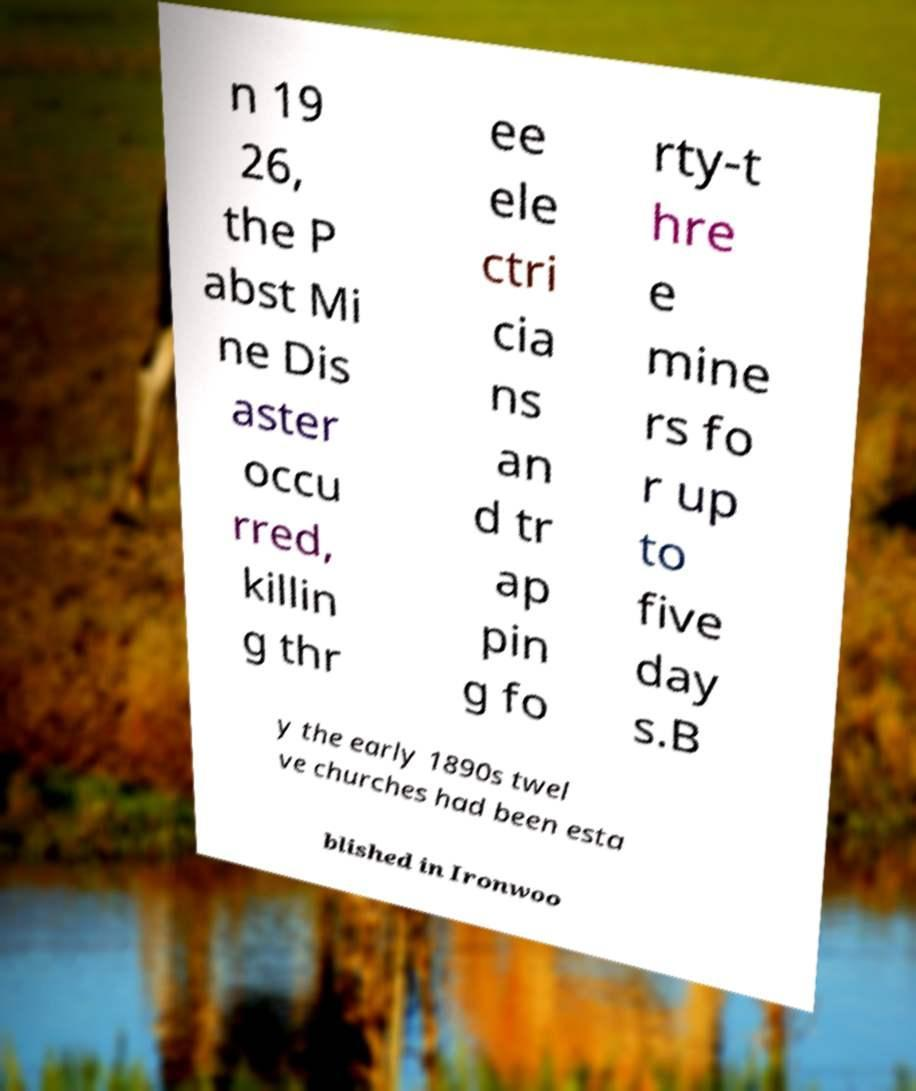Please identify and transcribe the text found in this image. n 19 26, the P abst Mi ne Dis aster occu rred, killin g thr ee ele ctri cia ns an d tr ap pin g fo rty-t hre e mine rs fo r up to five day s.B y the early 1890s twel ve churches had been esta blished in Ironwoo 